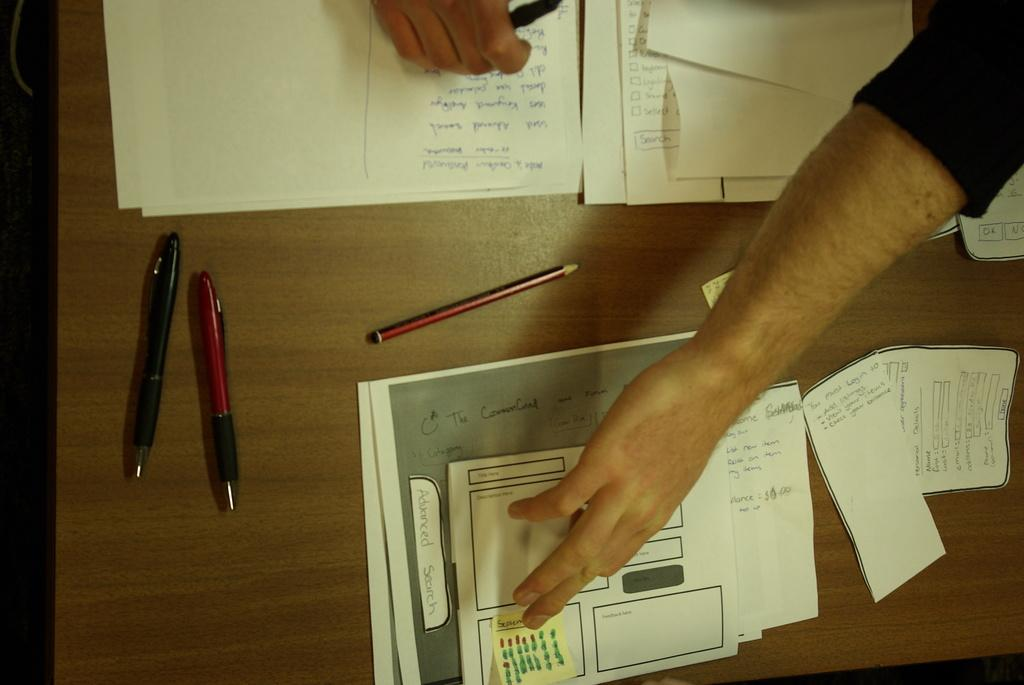What objects are on the table in the image? There are papers, a pencil, and pens on the table in the image. What might be used for writing or drawing on the papers? The pencil and pens on the table might be used for writing or drawing on the papers. Can you describe the hands visible in the image? There is a hand of a person visible, as well as the fingers of another person visible. How does the person comb their hair in the image? There is no indication in the image that anyone is combing their hair. 